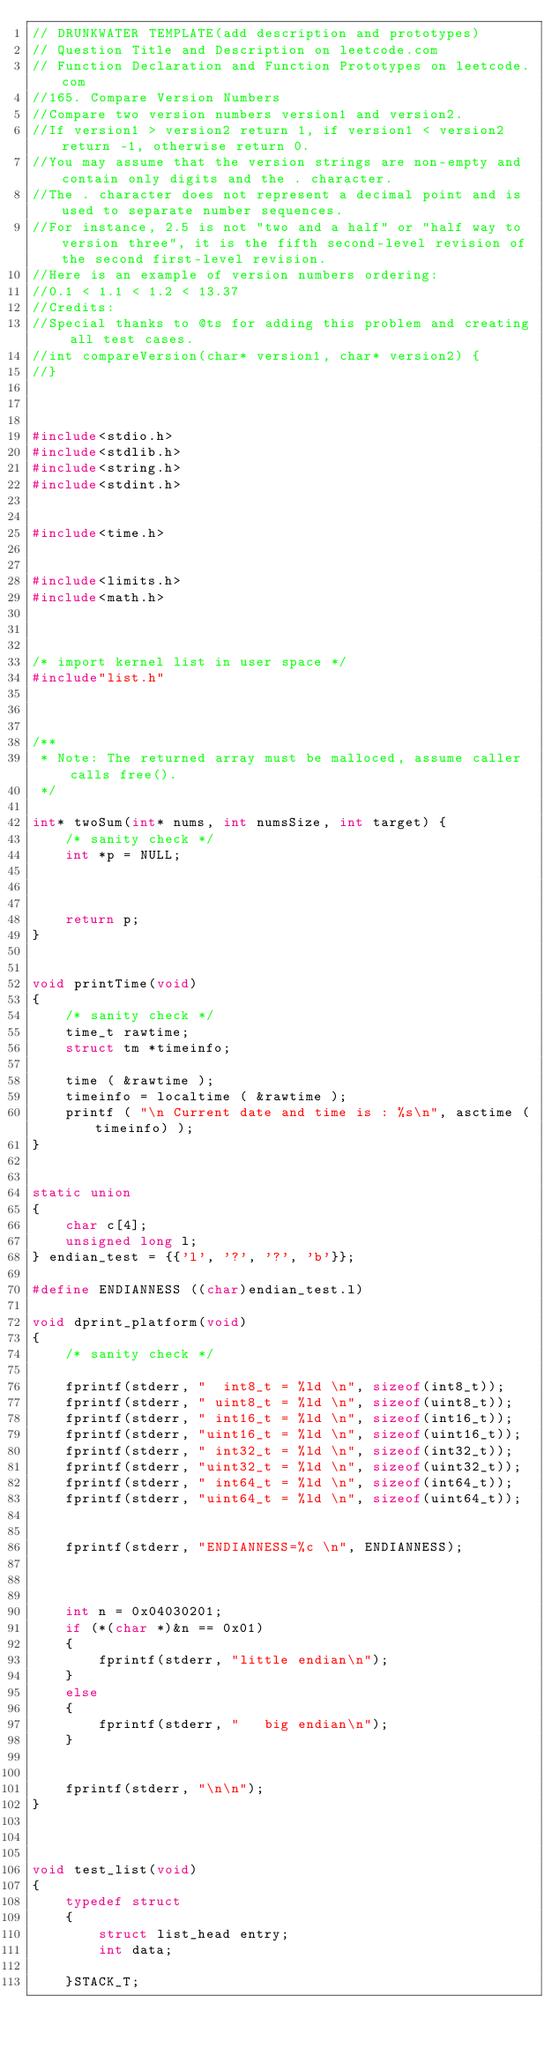<code> <loc_0><loc_0><loc_500><loc_500><_C_>// DRUNKWATER TEMPLATE(add description and prototypes)
// Question Title and Description on leetcode.com
// Function Declaration and Function Prototypes on leetcode.com
//165. Compare Version Numbers
//Compare two version numbers version1 and version2.
//If version1 > version2 return 1, if version1 < version2 return -1, otherwise return 0.
//You may assume that the version strings are non-empty and contain only digits and the . character.
//The . character does not represent a decimal point and is used to separate number sequences.
//For instance, 2.5 is not "two and a half" or "half way to version three", it is the fifth second-level revision of the second first-level revision.
//Here is an example of version numbers ordering:
//0.1 < 1.1 < 1.2 < 13.37
//Credits:
//Special thanks to @ts for adding this problem and creating all test cases.
//int compareVersion(char* version1, char* version2) {
//}



#include<stdio.h>
#include<stdlib.h>
#include<string.h>
#include<stdint.h>


#include<time.h>


#include<limits.h>
#include<math.h>



/* import kernel list in user space */
#include"list.h"



/**
 * Note: The returned array must be malloced, assume caller calls free().
 */

int* twoSum(int* nums, int numsSize, int target) {
	/* sanity check */
	int *p = NULL;



	return p;
}


void printTime(void)
{
	/* sanity check */
	time_t rawtime;
	struct tm *timeinfo;

	time ( &rawtime );
	timeinfo = localtime ( &rawtime );
	printf ( "\n Current date and time is : %s\n", asctime (timeinfo) );
}


static union
{
	char c[4];
	unsigned long l;
} endian_test = {{'l', '?', '?', 'b'}};

#define ENDIANNESS ((char)endian_test.l)

void dprint_platform(void)
{
	/* sanity check */

	fprintf(stderr, "  int8_t = %ld \n", sizeof(int8_t));
	fprintf(stderr, " uint8_t = %ld \n", sizeof(uint8_t));
	fprintf(stderr, " int16_t = %ld \n", sizeof(int16_t));
	fprintf(stderr, "uint16_t = %ld \n", sizeof(uint16_t));
	fprintf(stderr, " int32_t = %ld \n", sizeof(int32_t));
	fprintf(stderr, "uint32_t = %ld \n", sizeof(uint32_t));
	fprintf(stderr, " int64_t = %ld \n", sizeof(int64_t));
	fprintf(stderr, "uint64_t = %ld \n", sizeof(uint64_t));


	fprintf(stderr, "ENDIANNESS=%c \n", ENDIANNESS);



	int n = 0x04030201;
	if (*(char *)&n == 0x01)
	{
		fprintf(stderr, "little endian\n");
	}
	else
	{
		fprintf(stderr, "   big endian\n");
	}


	fprintf(stderr, "\n\n");
}



void test_list(void)
{
	typedef struct
	{
		struct list_head entry;
		int data;
	
	}STACK_T;
</code> 